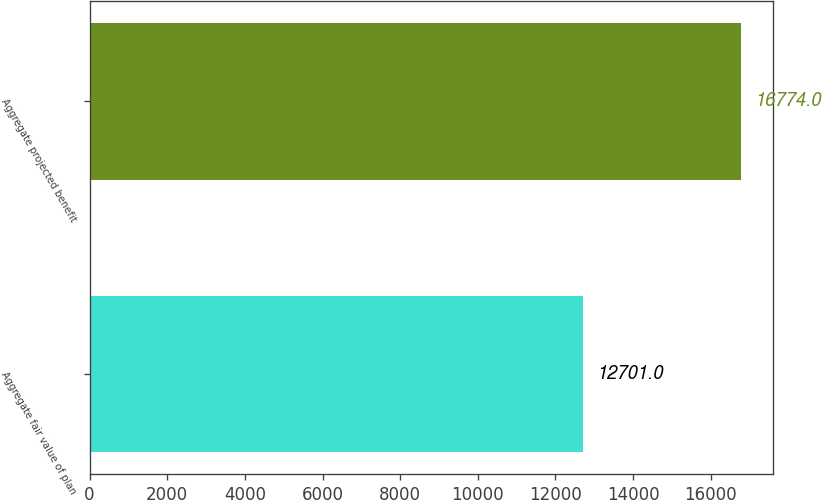<chart> <loc_0><loc_0><loc_500><loc_500><bar_chart><fcel>Aggregate fair value of plan<fcel>Aggregate projected benefit<nl><fcel>12701<fcel>16774<nl></chart> 